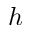Convert formula to latex. <formula><loc_0><loc_0><loc_500><loc_500>h</formula> 